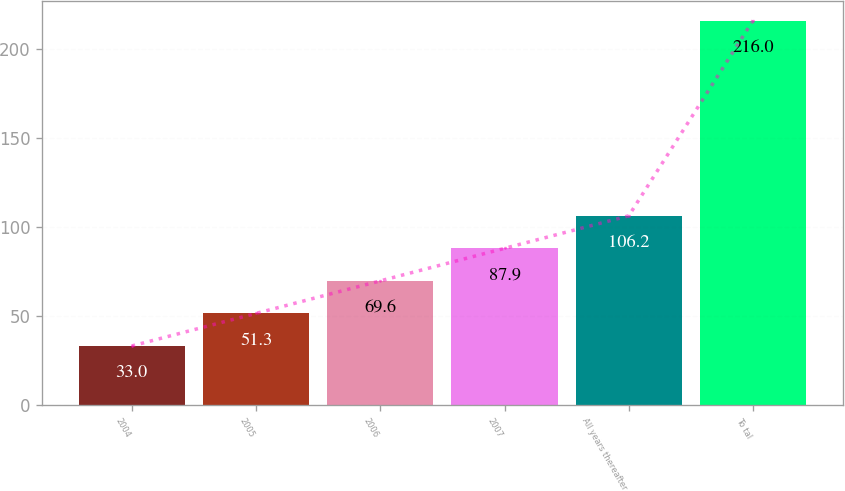Convert chart. <chart><loc_0><loc_0><loc_500><loc_500><bar_chart><fcel>2004<fcel>2005<fcel>2006<fcel>2007<fcel>All years thereafter<fcel>To tal<nl><fcel>33<fcel>51.3<fcel>69.6<fcel>87.9<fcel>106.2<fcel>216<nl></chart> 